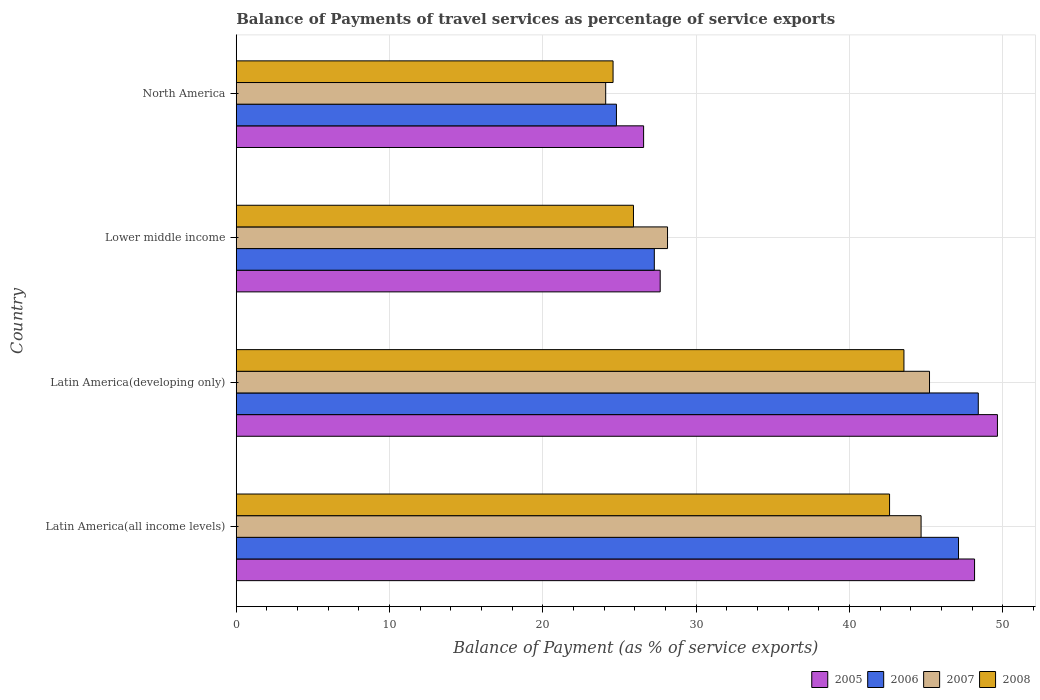How many groups of bars are there?
Your answer should be compact. 4. Are the number of bars on each tick of the Y-axis equal?
Provide a succinct answer. Yes. How many bars are there on the 3rd tick from the top?
Keep it short and to the point. 4. What is the label of the 3rd group of bars from the top?
Ensure brevity in your answer.  Latin America(developing only). What is the balance of payments of travel services in 2007 in Lower middle income?
Keep it short and to the point. 28.13. Across all countries, what is the maximum balance of payments of travel services in 2007?
Provide a succinct answer. 45.22. Across all countries, what is the minimum balance of payments of travel services in 2006?
Ensure brevity in your answer.  24.8. In which country was the balance of payments of travel services in 2007 maximum?
Your answer should be compact. Latin America(developing only). In which country was the balance of payments of travel services in 2005 minimum?
Make the answer very short. North America. What is the total balance of payments of travel services in 2008 in the graph?
Make the answer very short. 136.65. What is the difference between the balance of payments of travel services in 2008 in Latin America(all income levels) and that in Lower middle income?
Give a very brief answer. 16.7. What is the difference between the balance of payments of travel services in 2005 in Latin America(developing only) and the balance of payments of travel services in 2006 in Lower middle income?
Keep it short and to the point. 22.38. What is the average balance of payments of travel services in 2008 per country?
Make the answer very short. 34.16. What is the difference between the balance of payments of travel services in 2008 and balance of payments of travel services in 2006 in North America?
Give a very brief answer. -0.22. What is the ratio of the balance of payments of travel services in 2006 in Latin America(all income levels) to that in Latin America(developing only)?
Make the answer very short. 0.97. Is the balance of payments of travel services in 2007 in Latin America(all income levels) less than that in Lower middle income?
Provide a short and direct response. No. What is the difference between the highest and the second highest balance of payments of travel services in 2005?
Provide a succinct answer. 1.49. What is the difference between the highest and the lowest balance of payments of travel services in 2008?
Provide a succinct answer. 18.97. Is it the case that in every country, the sum of the balance of payments of travel services in 2006 and balance of payments of travel services in 2005 is greater than the balance of payments of travel services in 2007?
Provide a succinct answer. Yes. How many bars are there?
Your answer should be compact. 16. Are all the bars in the graph horizontal?
Provide a short and direct response. Yes. Are the values on the major ticks of X-axis written in scientific E-notation?
Offer a very short reply. No. What is the title of the graph?
Keep it short and to the point. Balance of Payments of travel services as percentage of service exports. Does "1995" appear as one of the legend labels in the graph?
Provide a short and direct response. No. What is the label or title of the X-axis?
Keep it short and to the point. Balance of Payment (as % of service exports). What is the Balance of Payment (as % of service exports) of 2005 in Latin America(all income levels)?
Your answer should be compact. 48.16. What is the Balance of Payment (as % of service exports) in 2006 in Latin America(all income levels)?
Give a very brief answer. 47.11. What is the Balance of Payment (as % of service exports) of 2007 in Latin America(all income levels)?
Keep it short and to the point. 44.67. What is the Balance of Payment (as % of service exports) of 2008 in Latin America(all income levels)?
Make the answer very short. 42.61. What is the Balance of Payment (as % of service exports) of 2005 in Latin America(developing only)?
Your answer should be very brief. 49.65. What is the Balance of Payment (as % of service exports) in 2006 in Latin America(developing only)?
Your answer should be compact. 48.4. What is the Balance of Payment (as % of service exports) of 2007 in Latin America(developing only)?
Provide a succinct answer. 45.22. What is the Balance of Payment (as % of service exports) of 2008 in Latin America(developing only)?
Keep it short and to the point. 43.55. What is the Balance of Payment (as % of service exports) in 2005 in Lower middle income?
Provide a succinct answer. 27.65. What is the Balance of Payment (as % of service exports) in 2006 in Lower middle income?
Make the answer very short. 27.27. What is the Balance of Payment (as % of service exports) of 2007 in Lower middle income?
Keep it short and to the point. 28.13. What is the Balance of Payment (as % of service exports) in 2008 in Lower middle income?
Provide a succinct answer. 25.91. What is the Balance of Payment (as % of service exports) of 2005 in North America?
Offer a very short reply. 26.57. What is the Balance of Payment (as % of service exports) of 2006 in North America?
Provide a succinct answer. 24.8. What is the Balance of Payment (as % of service exports) of 2007 in North America?
Give a very brief answer. 24.1. What is the Balance of Payment (as % of service exports) of 2008 in North America?
Keep it short and to the point. 24.58. Across all countries, what is the maximum Balance of Payment (as % of service exports) in 2005?
Offer a terse response. 49.65. Across all countries, what is the maximum Balance of Payment (as % of service exports) of 2006?
Your response must be concise. 48.4. Across all countries, what is the maximum Balance of Payment (as % of service exports) in 2007?
Offer a very short reply. 45.22. Across all countries, what is the maximum Balance of Payment (as % of service exports) in 2008?
Offer a very short reply. 43.55. Across all countries, what is the minimum Balance of Payment (as % of service exports) in 2005?
Your answer should be very brief. 26.57. Across all countries, what is the minimum Balance of Payment (as % of service exports) of 2006?
Offer a very short reply. 24.8. Across all countries, what is the minimum Balance of Payment (as % of service exports) of 2007?
Your answer should be very brief. 24.1. Across all countries, what is the minimum Balance of Payment (as % of service exports) of 2008?
Ensure brevity in your answer.  24.58. What is the total Balance of Payment (as % of service exports) in 2005 in the graph?
Your answer should be very brief. 152.02. What is the total Balance of Payment (as % of service exports) of 2006 in the graph?
Your answer should be very brief. 147.57. What is the total Balance of Payment (as % of service exports) of 2007 in the graph?
Your response must be concise. 142.11. What is the total Balance of Payment (as % of service exports) in 2008 in the graph?
Keep it short and to the point. 136.65. What is the difference between the Balance of Payment (as % of service exports) in 2005 in Latin America(all income levels) and that in Latin America(developing only)?
Give a very brief answer. -1.49. What is the difference between the Balance of Payment (as % of service exports) of 2006 in Latin America(all income levels) and that in Latin America(developing only)?
Give a very brief answer. -1.29. What is the difference between the Balance of Payment (as % of service exports) of 2007 in Latin America(all income levels) and that in Latin America(developing only)?
Your answer should be compact. -0.55. What is the difference between the Balance of Payment (as % of service exports) of 2008 in Latin America(all income levels) and that in Latin America(developing only)?
Keep it short and to the point. -0.94. What is the difference between the Balance of Payment (as % of service exports) in 2005 in Latin America(all income levels) and that in Lower middle income?
Keep it short and to the point. 20.5. What is the difference between the Balance of Payment (as % of service exports) in 2006 in Latin America(all income levels) and that in Lower middle income?
Keep it short and to the point. 19.84. What is the difference between the Balance of Payment (as % of service exports) of 2007 in Latin America(all income levels) and that in Lower middle income?
Your answer should be very brief. 16.54. What is the difference between the Balance of Payment (as % of service exports) of 2008 in Latin America(all income levels) and that in Lower middle income?
Your answer should be very brief. 16.7. What is the difference between the Balance of Payment (as % of service exports) of 2005 in Latin America(all income levels) and that in North America?
Your answer should be very brief. 21.59. What is the difference between the Balance of Payment (as % of service exports) of 2006 in Latin America(all income levels) and that in North America?
Your answer should be very brief. 22.31. What is the difference between the Balance of Payment (as % of service exports) in 2007 in Latin America(all income levels) and that in North America?
Provide a succinct answer. 20.57. What is the difference between the Balance of Payment (as % of service exports) of 2008 in Latin America(all income levels) and that in North America?
Give a very brief answer. 18.04. What is the difference between the Balance of Payment (as % of service exports) of 2005 in Latin America(developing only) and that in Lower middle income?
Offer a very short reply. 22. What is the difference between the Balance of Payment (as % of service exports) of 2006 in Latin America(developing only) and that in Lower middle income?
Ensure brevity in your answer.  21.13. What is the difference between the Balance of Payment (as % of service exports) in 2007 in Latin America(developing only) and that in Lower middle income?
Make the answer very short. 17.09. What is the difference between the Balance of Payment (as % of service exports) in 2008 in Latin America(developing only) and that in Lower middle income?
Make the answer very short. 17.64. What is the difference between the Balance of Payment (as % of service exports) of 2005 in Latin America(developing only) and that in North America?
Your response must be concise. 23.08. What is the difference between the Balance of Payment (as % of service exports) of 2006 in Latin America(developing only) and that in North America?
Ensure brevity in your answer.  23.6. What is the difference between the Balance of Payment (as % of service exports) of 2007 in Latin America(developing only) and that in North America?
Make the answer very short. 21.12. What is the difference between the Balance of Payment (as % of service exports) of 2008 in Latin America(developing only) and that in North America?
Your response must be concise. 18.97. What is the difference between the Balance of Payment (as % of service exports) of 2005 in Lower middle income and that in North America?
Make the answer very short. 1.08. What is the difference between the Balance of Payment (as % of service exports) of 2006 in Lower middle income and that in North America?
Offer a very short reply. 2.47. What is the difference between the Balance of Payment (as % of service exports) in 2007 in Lower middle income and that in North America?
Your response must be concise. 4.03. What is the difference between the Balance of Payment (as % of service exports) in 2008 in Lower middle income and that in North America?
Your response must be concise. 1.33. What is the difference between the Balance of Payment (as % of service exports) of 2005 in Latin America(all income levels) and the Balance of Payment (as % of service exports) of 2006 in Latin America(developing only)?
Your answer should be very brief. -0.24. What is the difference between the Balance of Payment (as % of service exports) in 2005 in Latin America(all income levels) and the Balance of Payment (as % of service exports) in 2007 in Latin America(developing only)?
Offer a terse response. 2.94. What is the difference between the Balance of Payment (as % of service exports) of 2005 in Latin America(all income levels) and the Balance of Payment (as % of service exports) of 2008 in Latin America(developing only)?
Offer a terse response. 4.61. What is the difference between the Balance of Payment (as % of service exports) of 2006 in Latin America(all income levels) and the Balance of Payment (as % of service exports) of 2007 in Latin America(developing only)?
Your answer should be very brief. 1.89. What is the difference between the Balance of Payment (as % of service exports) in 2006 in Latin America(all income levels) and the Balance of Payment (as % of service exports) in 2008 in Latin America(developing only)?
Your answer should be very brief. 3.56. What is the difference between the Balance of Payment (as % of service exports) in 2007 in Latin America(all income levels) and the Balance of Payment (as % of service exports) in 2008 in Latin America(developing only)?
Ensure brevity in your answer.  1.12. What is the difference between the Balance of Payment (as % of service exports) in 2005 in Latin America(all income levels) and the Balance of Payment (as % of service exports) in 2006 in Lower middle income?
Provide a short and direct response. 20.89. What is the difference between the Balance of Payment (as % of service exports) of 2005 in Latin America(all income levels) and the Balance of Payment (as % of service exports) of 2007 in Lower middle income?
Offer a very short reply. 20.03. What is the difference between the Balance of Payment (as % of service exports) of 2005 in Latin America(all income levels) and the Balance of Payment (as % of service exports) of 2008 in Lower middle income?
Offer a very short reply. 22.25. What is the difference between the Balance of Payment (as % of service exports) of 2006 in Latin America(all income levels) and the Balance of Payment (as % of service exports) of 2007 in Lower middle income?
Provide a short and direct response. 18.98. What is the difference between the Balance of Payment (as % of service exports) of 2006 in Latin America(all income levels) and the Balance of Payment (as % of service exports) of 2008 in Lower middle income?
Offer a terse response. 21.2. What is the difference between the Balance of Payment (as % of service exports) in 2007 in Latin America(all income levels) and the Balance of Payment (as % of service exports) in 2008 in Lower middle income?
Your answer should be very brief. 18.76. What is the difference between the Balance of Payment (as % of service exports) in 2005 in Latin America(all income levels) and the Balance of Payment (as % of service exports) in 2006 in North America?
Make the answer very short. 23.36. What is the difference between the Balance of Payment (as % of service exports) of 2005 in Latin America(all income levels) and the Balance of Payment (as % of service exports) of 2007 in North America?
Offer a terse response. 24.06. What is the difference between the Balance of Payment (as % of service exports) in 2005 in Latin America(all income levels) and the Balance of Payment (as % of service exports) in 2008 in North America?
Your response must be concise. 23.58. What is the difference between the Balance of Payment (as % of service exports) of 2006 in Latin America(all income levels) and the Balance of Payment (as % of service exports) of 2007 in North America?
Make the answer very short. 23.01. What is the difference between the Balance of Payment (as % of service exports) of 2006 in Latin America(all income levels) and the Balance of Payment (as % of service exports) of 2008 in North America?
Ensure brevity in your answer.  22.53. What is the difference between the Balance of Payment (as % of service exports) of 2007 in Latin America(all income levels) and the Balance of Payment (as % of service exports) of 2008 in North America?
Your answer should be compact. 20.09. What is the difference between the Balance of Payment (as % of service exports) in 2005 in Latin America(developing only) and the Balance of Payment (as % of service exports) in 2006 in Lower middle income?
Provide a succinct answer. 22.38. What is the difference between the Balance of Payment (as % of service exports) of 2005 in Latin America(developing only) and the Balance of Payment (as % of service exports) of 2007 in Lower middle income?
Give a very brief answer. 21.52. What is the difference between the Balance of Payment (as % of service exports) of 2005 in Latin America(developing only) and the Balance of Payment (as % of service exports) of 2008 in Lower middle income?
Your answer should be very brief. 23.74. What is the difference between the Balance of Payment (as % of service exports) in 2006 in Latin America(developing only) and the Balance of Payment (as % of service exports) in 2007 in Lower middle income?
Make the answer very short. 20.27. What is the difference between the Balance of Payment (as % of service exports) in 2006 in Latin America(developing only) and the Balance of Payment (as % of service exports) in 2008 in Lower middle income?
Your answer should be very brief. 22.49. What is the difference between the Balance of Payment (as % of service exports) in 2007 in Latin America(developing only) and the Balance of Payment (as % of service exports) in 2008 in Lower middle income?
Ensure brevity in your answer.  19.31. What is the difference between the Balance of Payment (as % of service exports) of 2005 in Latin America(developing only) and the Balance of Payment (as % of service exports) of 2006 in North America?
Provide a succinct answer. 24.85. What is the difference between the Balance of Payment (as % of service exports) in 2005 in Latin America(developing only) and the Balance of Payment (as % of service exports) in 2007 in North America?
Your answer should be very brief. 25.55. What is the difference between the Balance of Payment (as % of service exports) in 2005 in Latin America(developing only) and the Balance of Payment (as % of service exports) in 2008 in North America?
Keep it short and to the point. 25.07. What is the difference between the Balance of Payment (as % of service exports) of 2006 in Latin America(developing only) and the Balance of Payment (as % of service exports) of 2007 in North America?
Give a very brief answer. 24.3. What is the difference between the Balance of Payment (as % of service exports) in 2006 in Latin America(developing only) and the Balance of Payment (as % of service exports) in 2008 in North America?
Your response must be concise. 23.82. What is the difference between the Balance of Payment (as % of service exports) in 2007 in Latin America(developing only) and the Balance of Payment (as % of service exports) in 2008 in North America?
Offer a very short reply. 20.64. What is the difference between the Balance of Payment (as % of service exports) of 2005 in Lower middle income and the Balance of Payment (as % of service exports) of 2006 in North America?
Give a very brief answer. 2.85. What is the difference between the Balance of Payment (as % of service exports) of 2005 in Lower middle income and the Balance of Payment (as % of service exports) of 2007 in North America?
Give a very brief answer. 3.56. What is the difference between the Balance of Payment (as % of service exports) of 2005 in Lower middle income and the Balance of Payment (as % of service exports) of 2008 in North America?
Provide a succinct answer. 3.07. What is the difference between the Balance of Payment (as % of service exports) of 2006 in Lower middle income and the Balance of Payment (as % of service exports) of 2007 in North America?
Your response must be concise. 3.17. What is the difference between the Balance of Payment (as % of service exports) in 2006 in Lower middle income and the Balance of Payment (as % of service exports) in 2008 in North America?
Provide a succinct answer. 2.69. What is the difference between the Balance of Payment (as % of service exports) in 2007 in Lower middle income and the Balance of Payment (as % of service exports) in 2008 in North America?
Your response must be concise. 3.55. What is the average Balance of Payment (as % of service exports) of 2005 per country?
Offer a terse response. 38.01. What is the average Balance of Payment (as % of service exports) of 2006 per country?
Make the answer very short. 36.89. What is the average Balance of Payment (as % of service exports) in 2007 per country?
Provide a succinct answer. 35.53. What is the average Balance of Payment (as % of service exports) of 2008 per country?
Give a very brief answer. 34.16. What is the difference between the Balance of Payment (as % of service exports) in 2005 and Balance of Payment (as % of service exports) in 2006 in Latin America(all income levels)?
Keep it short and to the point. 1.05. What is the difference between the Balance of Payment (as % of service exports) in 2005 and Balance of Payment (as % of service exports) in 2007 in Latin America(all income levels)?
Your answer should be compact. 3.49. What is the difference between the Balance of Payment (as % of service exports) of 2005 and Balance of Payment (as % of service exports) of 2008 in Latin America(all income levels)?
Ensure brevity in your answer.  5.54. What is the difference between the Balance of Payment (as % of service exports) of 2006 and Balance of Payment (as % of service exports) of 2007 in Latin America(all income levels)?
Make the answer very short. 2.44. What is the difference between the Balance of Payment (as % of service exports) in 2006 and Balance of Payment (as % of service exports) in 2008 in Latin America(all income levels)?
Provide a short and direct response. 4.5. What is the difference between the Balance of Payment (as % of service exports) of 2007 and Balance of Payment (as % of service exports) of 2008 in Latin America(all income levels)?
Give a very brief answer. 2.05. What is the difference between the Balance of Payment (as % of service exports) in 2005 and Balance of Payment (as % of service exports) in 2006 in Latin America(developing only)?
Make the answer very short. 1.25. What is the difference between the Balance of Payment (as % of service exports) in 2005 and Balance of Payment (as % of service exports) in 2007 in Latin America(developing only)?
Provide a succinct answer. 4.43. What is the difference between the Balance of Payment (as % of service exports) of 2005 and Balance of Payment (as % of service exports) of 2008 in Latin America(developing only)?
Your answer should be compact. 6.1. What is the difference between the Balance of Payment (as % of service exports) in 2006 and Balance of Payment (as % of service exports) in 2007 in Latin America(developing only)?
Your answer should be very brief. 3.18. What is the difference between the Balance of Payment (as % of service exports) of 2006 and Balance of Payment (as % of service exports) of 2008 in Latin America(developing only)?
Offer a terse response. 4.85. What is the difference between the Balance of Payment (as % of service exports) of 2007 and Balance of Payment (as % of service exports) of 2008 in Latin America(developing only)?
Make the answer very short. 1.67. What is the difference between the Balance of Payment (as % of service exports) of 2005 and Balance of Payment (as % of service exports) of 2006 in Lower middle income?
Offer a very short reply. 0.38. What is the difference between the Balance of Payment (as % of service exports) of 2005 and Balance of Payment (as % of service exports) of 2007 in Lower middle income?
Your answer should be very brief. -0.48. What is the difference between the Balance of Payment (as % of service exports) of 2005 and Balance of Payment (as % of service exports) of 2008 in Lower middle income?
Keep it short and to the point. 1.74. What is the difference between the Balance of Payment (as % of service exports) of 2006 and Balance of Payment (as % of service exports) of 2007 in Lower middle income?
Make the answer very short. -0.86. What is the difference between the Balance of Payment (as % of service exports) of 2006 and Balance of Payment (as % of service exports) of 2008 in Lower middle income?
Your answer should be very brief. 1.36. What is the difference between the Balance of Payment (as % of service exports) in 2007 and Balance of Payment (as % of service exports) in 2008 in Lower middle income?
Make the answer very short. 2.22. What is the difference between the Balance of Payment (as % of service exports) of 2005 and Balance of Payment (as % of service exports) of 2006 in North America?
Give a very brief answer. 1.77. What is the difference between the Balance of Payment (as % of service exports) of 2005 and Balance of Payment (as % of service exports) of 2007 in North America?
Provide a succinct answer. 2.47. What is the difference between the Balance of Payment (as % of service exports) of 2005 and Balance of Payment (as % of service exports) of 2008 in North America?
Your answer should be compact. 1.99. What is the difference between the Balance of Payment (as % of service exports) in 2006 and Balance of Payment (as % of service exports) in 2007 in North America?
Your answer should be very brief. 0.7. What is the difference between the Balance of Payment (as % of service exports) in 2006 and Balance of Payment (as % of service exports) in 2008 in North America?
Keep it short and to the point. 0.22. What is the difference between the Balance of Payment (as % of service exports) in 2007 and Balance of Payment (as % of service exports) in 2008 in North America?
Offer a very short reply. -0.48. What is the ratio of the Balance of Payment (as % of service exports) of 2006 in Latin America(all income levels) to that in Latin America(developing only)?
Offer a very short reply. 0.97. What is the ratio of the Balance of Payment (as % of service exports) of 2008 in Latin America(all income levels) to that in Latin America(developing only)?
Provide a succinct answer. 0.98. What is the ratio of the Balance of Payment (as % of service exports) in 2005 in Latin America(all income levels) to that in Lower middle income?
Provide a short and direct response. 1.74. What is the ratio of the Balance of Payment (as % of service exports) in 2006 in Latin America(all income levels) to that in Lower middle income?
Offer a terse response. 1.73. What is the ratio of the Balance of Payment (as % of service exports) of 2007 in Latin America(all income levels) to that in Lower middle income?
Offer a terse response. 1.59. What is the ratio of the Balance of Payment (as % of service exports) of 2008 in Latin America(all income levels) to that in Lower middle income?
Ensure brevity in your answer.  1.64. What is the ratio of the Balance of Payment (as % of service exports) in 2005 in Latin America(all income levels) to that in North America?
Make the answer very short. 1.81. What is the ratio of the Balance of Payment (as % of service exports) of 2006 in Latin America(all income levels) to that in North America?
Provide a succinct answer. 1.9. What is the ratio of the Balance of Payment (as % of service exports) in 2007 in Latin America(all income levels) to that in North America?
Offer a very short reply. 1.85. What is the ratio of the Balance of Payment (as % of service exports) of 2008 in Latin America(all income levels) to that in North America?
Your answer should be compact. 1.73. What is the ratio of the Balance of Payment (as % of service exports) of 2005 in Latin America(developing only) to that in Lower middle income?
Provide a short and direct response. 1.8. What is the ratio of the Balance of Payment (as % of service exports) in 2006 in Latin America(developing only) to that in Lower middle income?
Offer a very short reply. 1.77. What is the ratio of the Balance of Payment (as % of service exports) in 2007 in Latin America(developing only) to that in Lower middle income?
Make the answer very short. 1.61. What is the ratio of the Balance of Payment (as % of service exports) in 2008 in Latin America(developing only) to that in Lower middle income?
Keep it short and to the point. 1.68. What is the ratio of the Balance of Payment (as % of service exports) of 2005 in Latin America(developing only) to that in North America?
Offer a very short reply. 1.87. What is the ratio of the Balance of Payment (as % of service exports) of 2006 in Latin America(developing only) to that in North America?
Provide a short and direct response. 1.95. What is the ratio of the Balance of Payment (as % of service exports) in 2007 in Latin America(developing only) to that in North America?
Make the answer very short. 1.88. What is the ratio of the Balance of Payment (as % of service exports) in 2008 in Latin America(developing only) to that in North America?
Ensure brevity in your answer.  1.77. What is the ratio of the Balance of Payment (as % of service exports) in 2005 in Lower middle income to that in North America?
Offer a very short reply. 1.04. What is the ratio of the Balance of Payment (as % of service exports) in 2006 in Lower middle income to that in North America?
Offer a very short reply. 1.1. What is the ratio of the Balance of Payment (as % of service exports) of 2007 in Lower middle income to that in North America?
Keep it short and to the point. 1.17. What is the ratio of the Balance of Payment (as % of service exports) of 2008 in Lower middle income to that in North America?
Offer a terse response. 1.05. What is the difference between the highest and the second highest Balance of Payment (as % of service exports) of 2005?
Provide a succinct answer. 1.49. What is the difference between the highest and the second highest Balance of Payment (as % of service exports) of 2006?
Give a very brief answer. 1.29. What is the difference between the highest and the second highest Balance of Payment (as % of service exports) of 2007?
Provide a short and direct response. 0.55. What is the difference between the highest and the second highest Balance of Payment (as % of service exports) in 2008?
Provide a short and direct response. 0.94. What is the difference between the highest and the lowest Balance of Payment (as % of service exports) of 2005?
Offer a terse response. 23.08. What is the difference between the highest and the lowest Balance of Payment (as % of service exports) of 2006?
Give a very brief answer. 23.6. What is the difference between the highest and the lowest Balance of Payment (as % of service exports) in 2007?
Offer a very short reply. 21.12. What is the difference between the highest and the lowest Balance of Payment (as % of service exports) in 2008?
Ensure brevity in your answer.  18.97. 